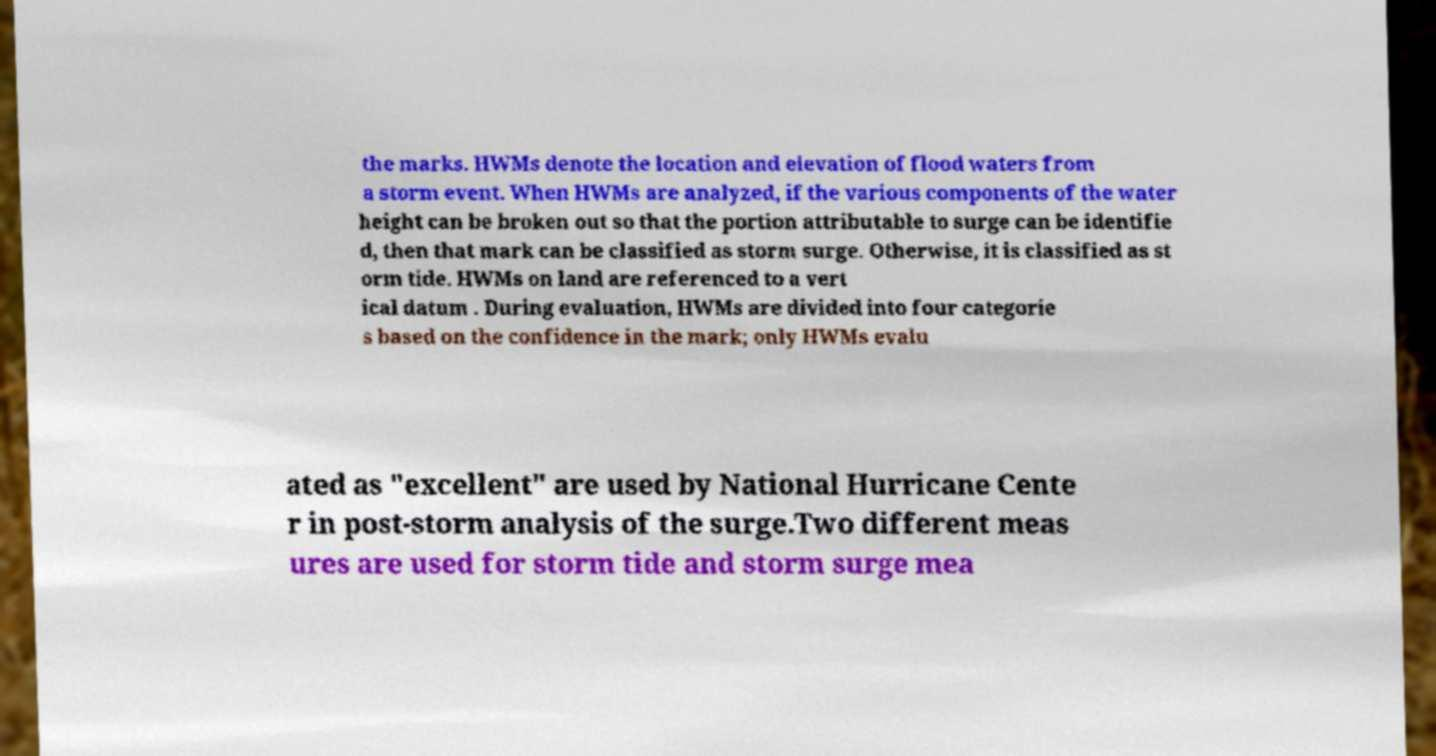Please identify and transcribe the text found in this image. the marks. HWMs denote the location and elevation of flood waters from a storm event. When HWMs are analyzed, if the various components of the water height can be broken out so that the portion attributable to surge can be identifie d, then that mark can be classified as storm surge. Otherwise, it is classified as st orm tide. HWMs on land are referenced to a vert ical datum . During evaluation, HWMs are divided into four categorie s based on the confidence in the mark; only HWMs evalu ated as "excellent" are used by National Hurricane Cente r in post-storm analysis of the surge.Two different meas ures are used for storm tide and storm surge mea 